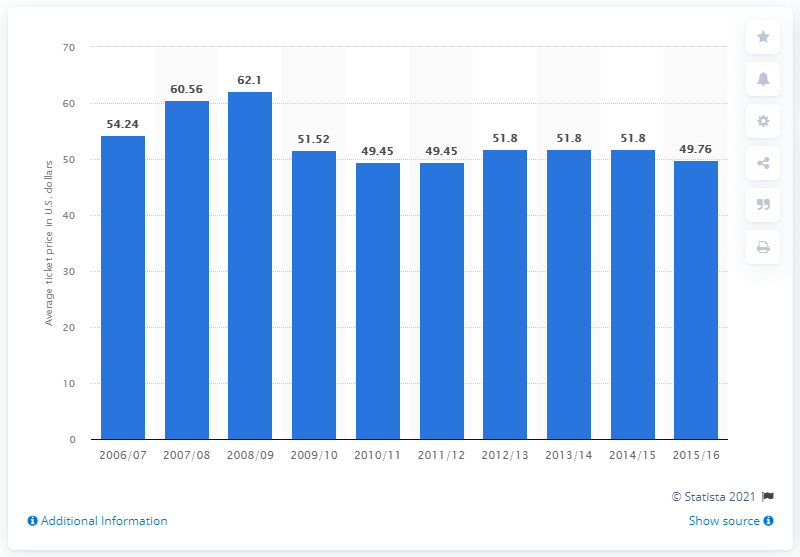Specify some key components in this picture. In the 2006/2007 season, the average ticket price for Dallas Mavericks games was $54.24. 